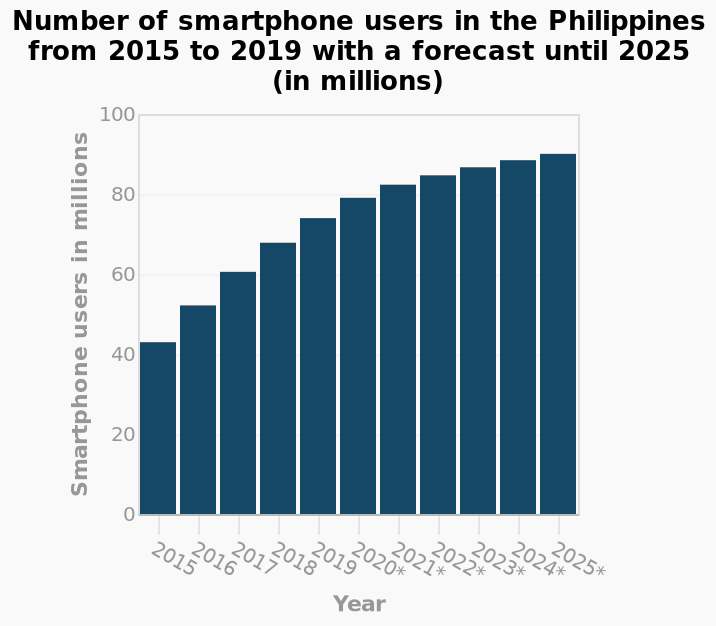<image>
Can we expect a decline in the number of smartphone users by 2025? No, based on the prediction, there is no expectation of a decline in the number of smartphone users by 2025. What is the range of the y-axis values? The range of the y-axis values is from 0 to 100 million smartphone users. 